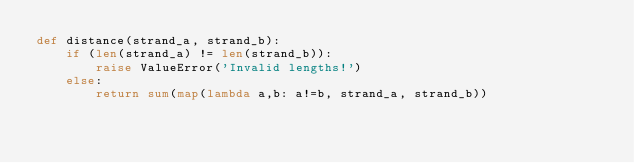<code> <loc_0><loc_0><loc_500><loc_500><_Python_>def distance(strand_a, strand_b):
    if (len(strand_a) != len(strand_b)):
        raise ValueError('Invalid lengths!')
    else:
        return sum(map(lambda a,b: a!=b, strand_a, strand_b))
</code> 